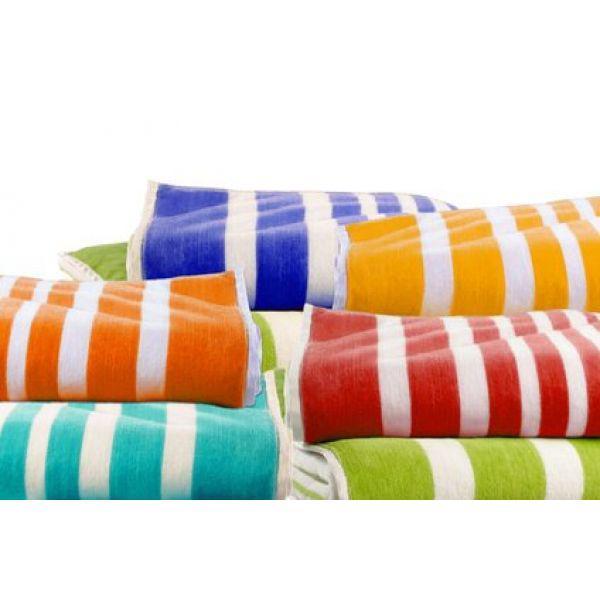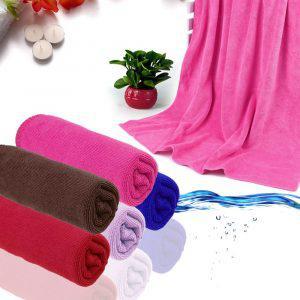The first image is the image on the left, the second image is the image on the right. For the images shown, is this caption "The towels on the right side image are rolled up." true? Answer yes or no. Yes. The first image is the image on the left, the second image is the image on the right. Analyze the images presented: Is the assertion "Towels in one image, each of them a different color, are folded into neat stacked squares." valid? Answer yes or no. No. 